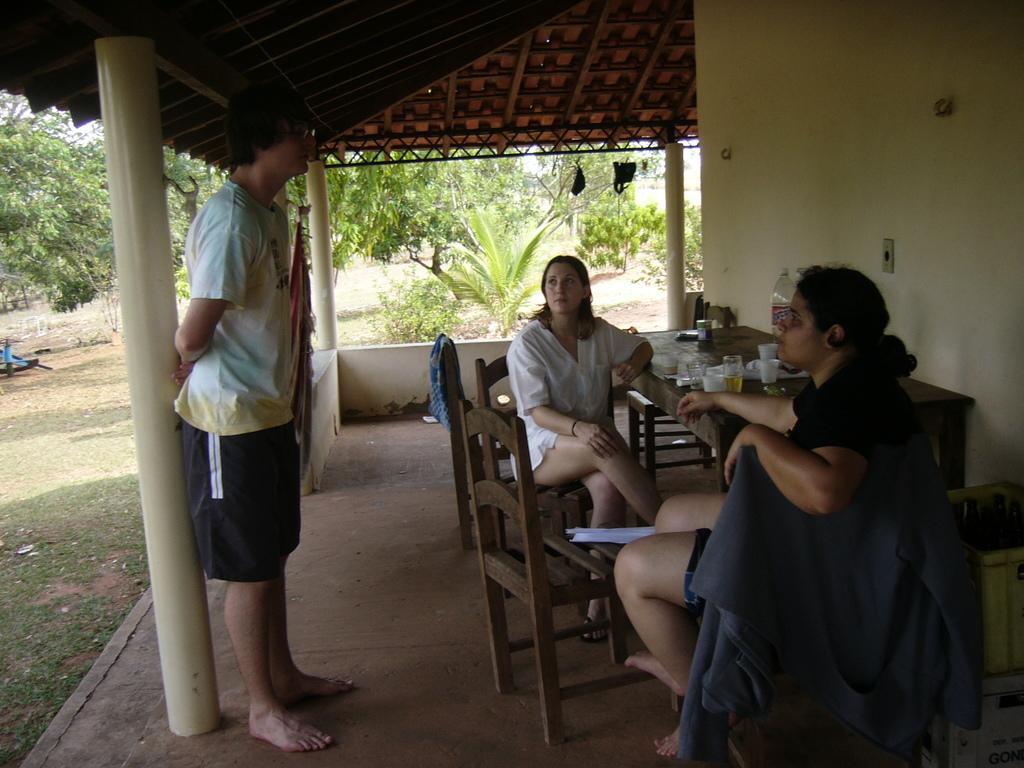How would you summarize this image in a sentence or two? There are two women sitting on the chair at the table and a man standing on the left. There are glasses,water bottle on the table. In the background there are trees and plants. 